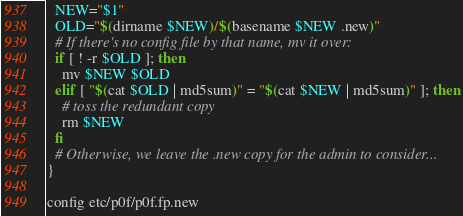Convert code to text. <code><loc_0><loc_0><loc_500><loc_500><_Bash_>  NEW="$1"
  OLD="$(dirname $NEW)/$(basename $NEW .new)"
  # If there's no config file by that name, mv it over:
  if [ ! -r $OLD ]; then
    mv $NEW $OLD
  elif [ "$(cat $OLD | md5sum)" = "$(cat $NEW | md5sum)" ]; then
    # toss the redundant copy
    rm $NEW
  fi
  # Otherwise, we leave the .new copy for the admin to consider...
}

config etc/p0f/p0f.fp.new
</code> 